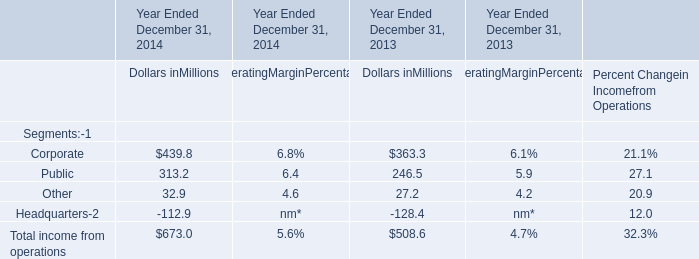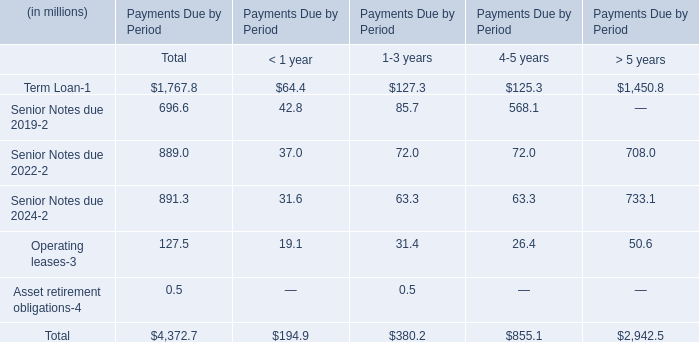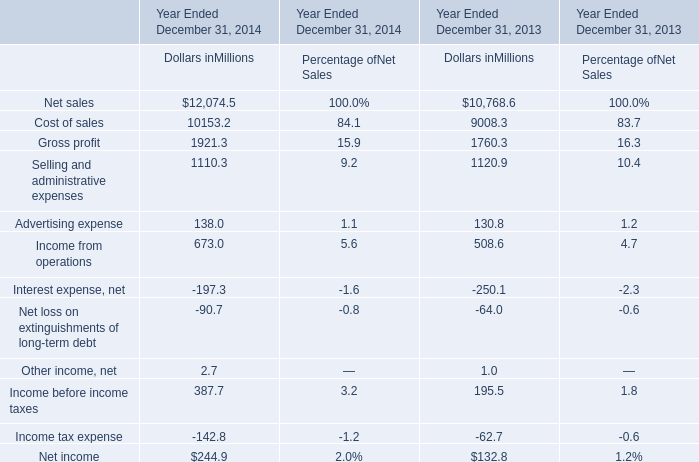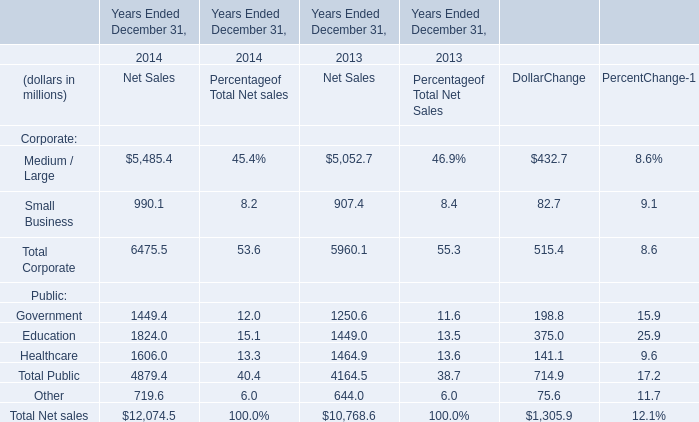What is the growing rate of Gross profit in the year with the most Net sales? 
Computations: ((1921.3 - 1760.3) / 1921.3)
Answer: 0.0838. 